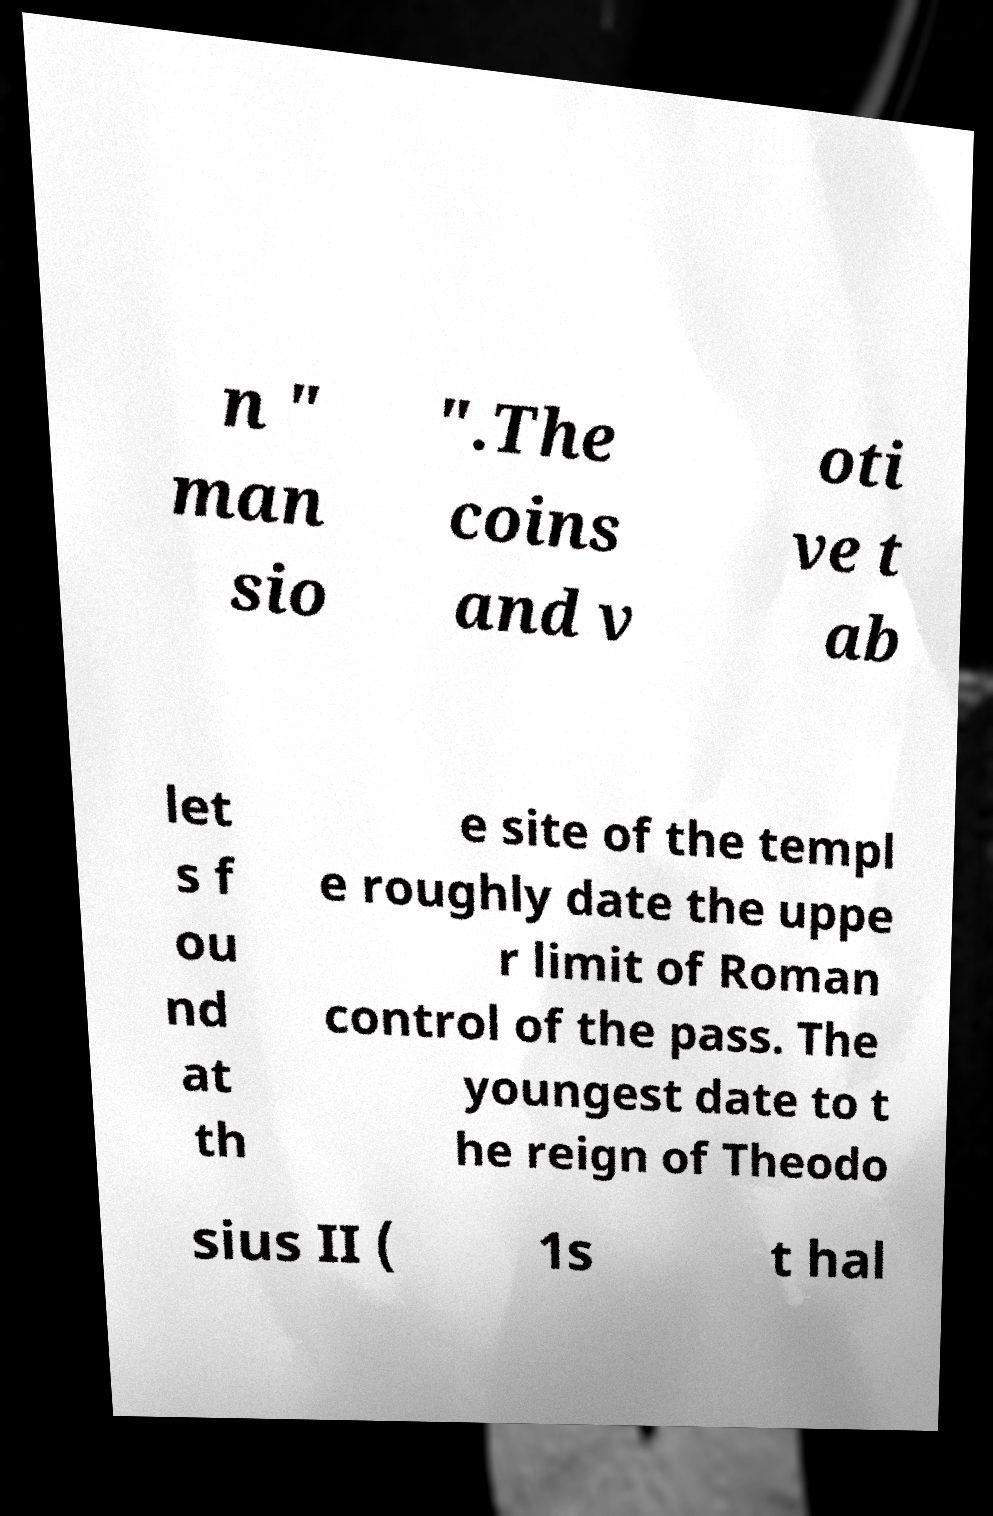I need the written content from this picture converted into text. Can you do that? n " man sio ".The coins and v oti ve t ab let s f ou nd at th e site of the templ e roughly date the uppe r limit of Roman control of the pass. The youngest date to t he reign of Theodo sius II ( 1s t hal 